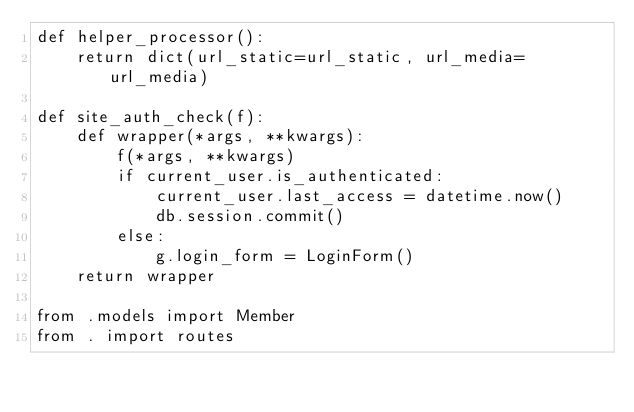Convert code to text. <code><loc_0><loc_0><loc_500><loc_500><_Python_>def helper_processor():
    return dict(url_static=url_static, url_media=url_media)

def site_auth_check(f):
    def wrapper(*args, **kwargs):
        f(*args, **kwargs)
        if current_user.is_authenticated:
            current_user.last_access = datetime.now()
            db.session.commit()
        else:
            g.login_form = LoginForm()
    return wrapper

from .models import Member
from . import routes
</code> 